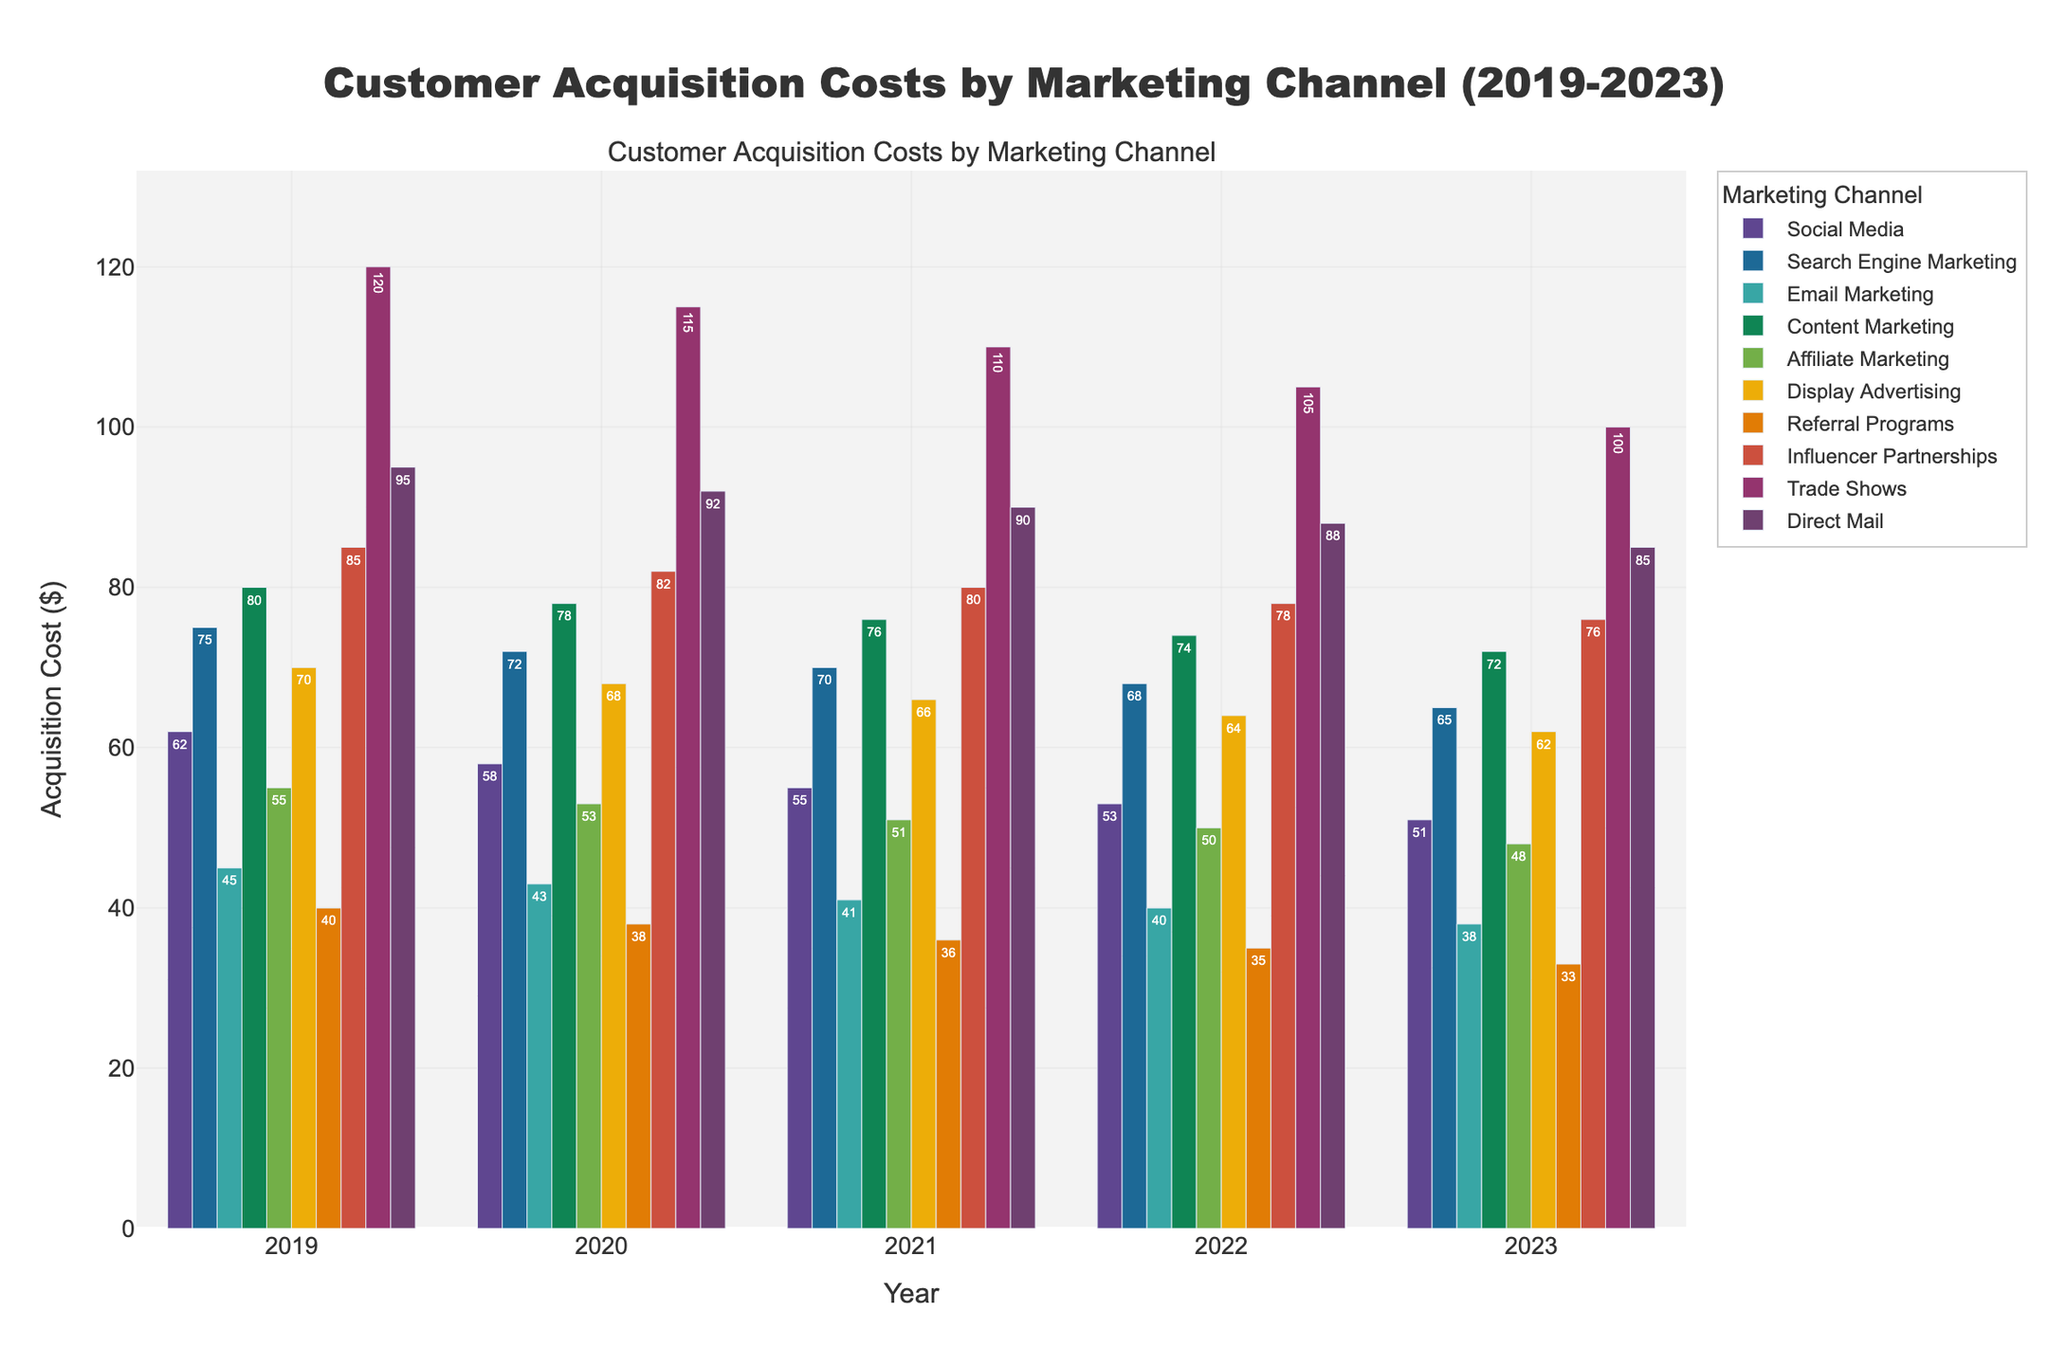What is the average acquisition cost for Search Engine Marketing over the past 5 years? Add the acquisition costs for Search Engine Marketing from 2019 to 2023 and divide by the number of years: (75 + 72 + 70 + 68 + 65) / 5 = 350 / 5
Answer: 70 Which marketing channel had the highest acquisition cost in 2023? Look at the bar heights for 2023 and identify the marketing channel with the highest bar. Trade Shows had the highest acquisition cost with 100 in 2023.
Answer: Trade Shows By how much did the acquisition cost decrease for Influencer Partnerships from 2019 to 2023? Subtract the cost in 2023 from the cost in 2019: 85 - 76 = 9
Answer: 9 Which marketing channel shows the most consistent decrease in acquisition costs over the past 5 years? Identify the marketing channel with a steadily decreasing trend in bar heights from 2019 to 2023. Content Marketing shows consistently decreasing acquisition costs (80, 78, 76, 74, 72) over the 5 years.
Answer: Content Marketing What is the difference in acquisition costs between Social Media and Email Marketing in 2021? Subtract the acquisition cost of Email Marketing from Social Media in 2021: 55 - 41 = 14
Answer: 14 Which marketing channel had the largest decrease in acquisition costs from 2019 to 2023? Calculate the decrease for each channel (cost in 2019 - cost in 2023) and find the maximum. Trade Shows had the largest decrease: 120 - 100 = 20
Answer: Trade Shows Is there any marketing channel whose acquisition cost remained the highest each year? Compare the highest costs for each year across all marketing channels. Trade Shows consistently had the highest acquisition costs each year from 2019 to 2023.
Answer: Yes, Trade Shows What is the cumulative acquisition cost for Display Advertising from 2019 to 2023? Add the acquisition costs for Display Advertising from 2019 to 2023: 70 + 68 + 66 + 64 + 62 = 330
Answer: 330 Which two marketing channels had the closest acquisition costs in 2022? Look at the bars for 2022 and find the two channels with closest values. Social Media and Email Marketing had acquisition costs of 53 and 50, respectively, which are the closest.
Answer: Social Media and Email Marketing 